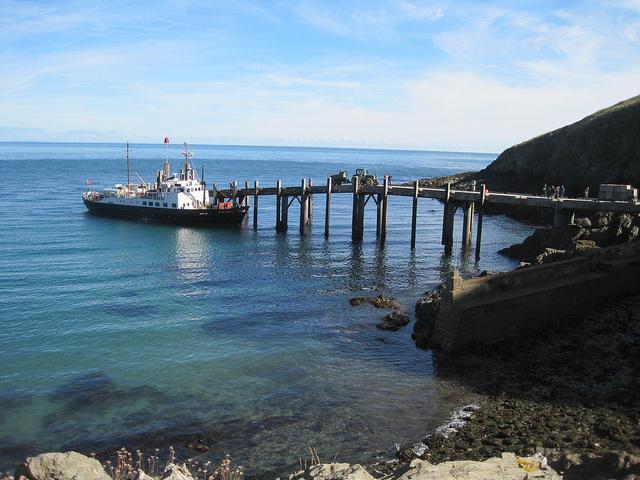How many boats are docked at this pier?
Give a very brief answer. 1. How many little elephants are in the image?
Give a very brief answer. 0. 